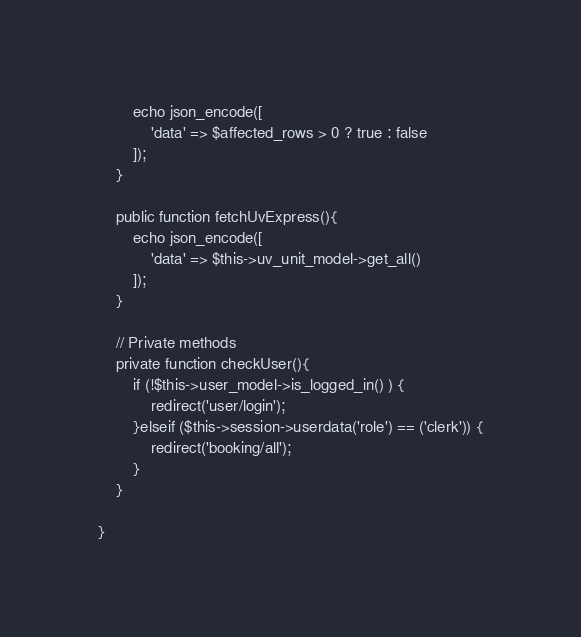Convert code to text. <code><loc_0><loc_0><loc_500><loc_500><_PHP_> 		echo json_encode([
			'data' => $affected_rows > 0 ? true : false
		]);
 	}

	public function fetchUvExpress(){
		echo json_encode([
			'data' => $this->uv_unit_model->get_all()
		]);
	}

	// Private methods
 	private function checkUser(){
 		if (!$this->user_model->is_logged_in() ) {
			redirect('user/login');
		}elseif ($this->session->userdata('role') == ('clerk')) {
			redirect('booking/all');
		}
 	}

}
</code> 